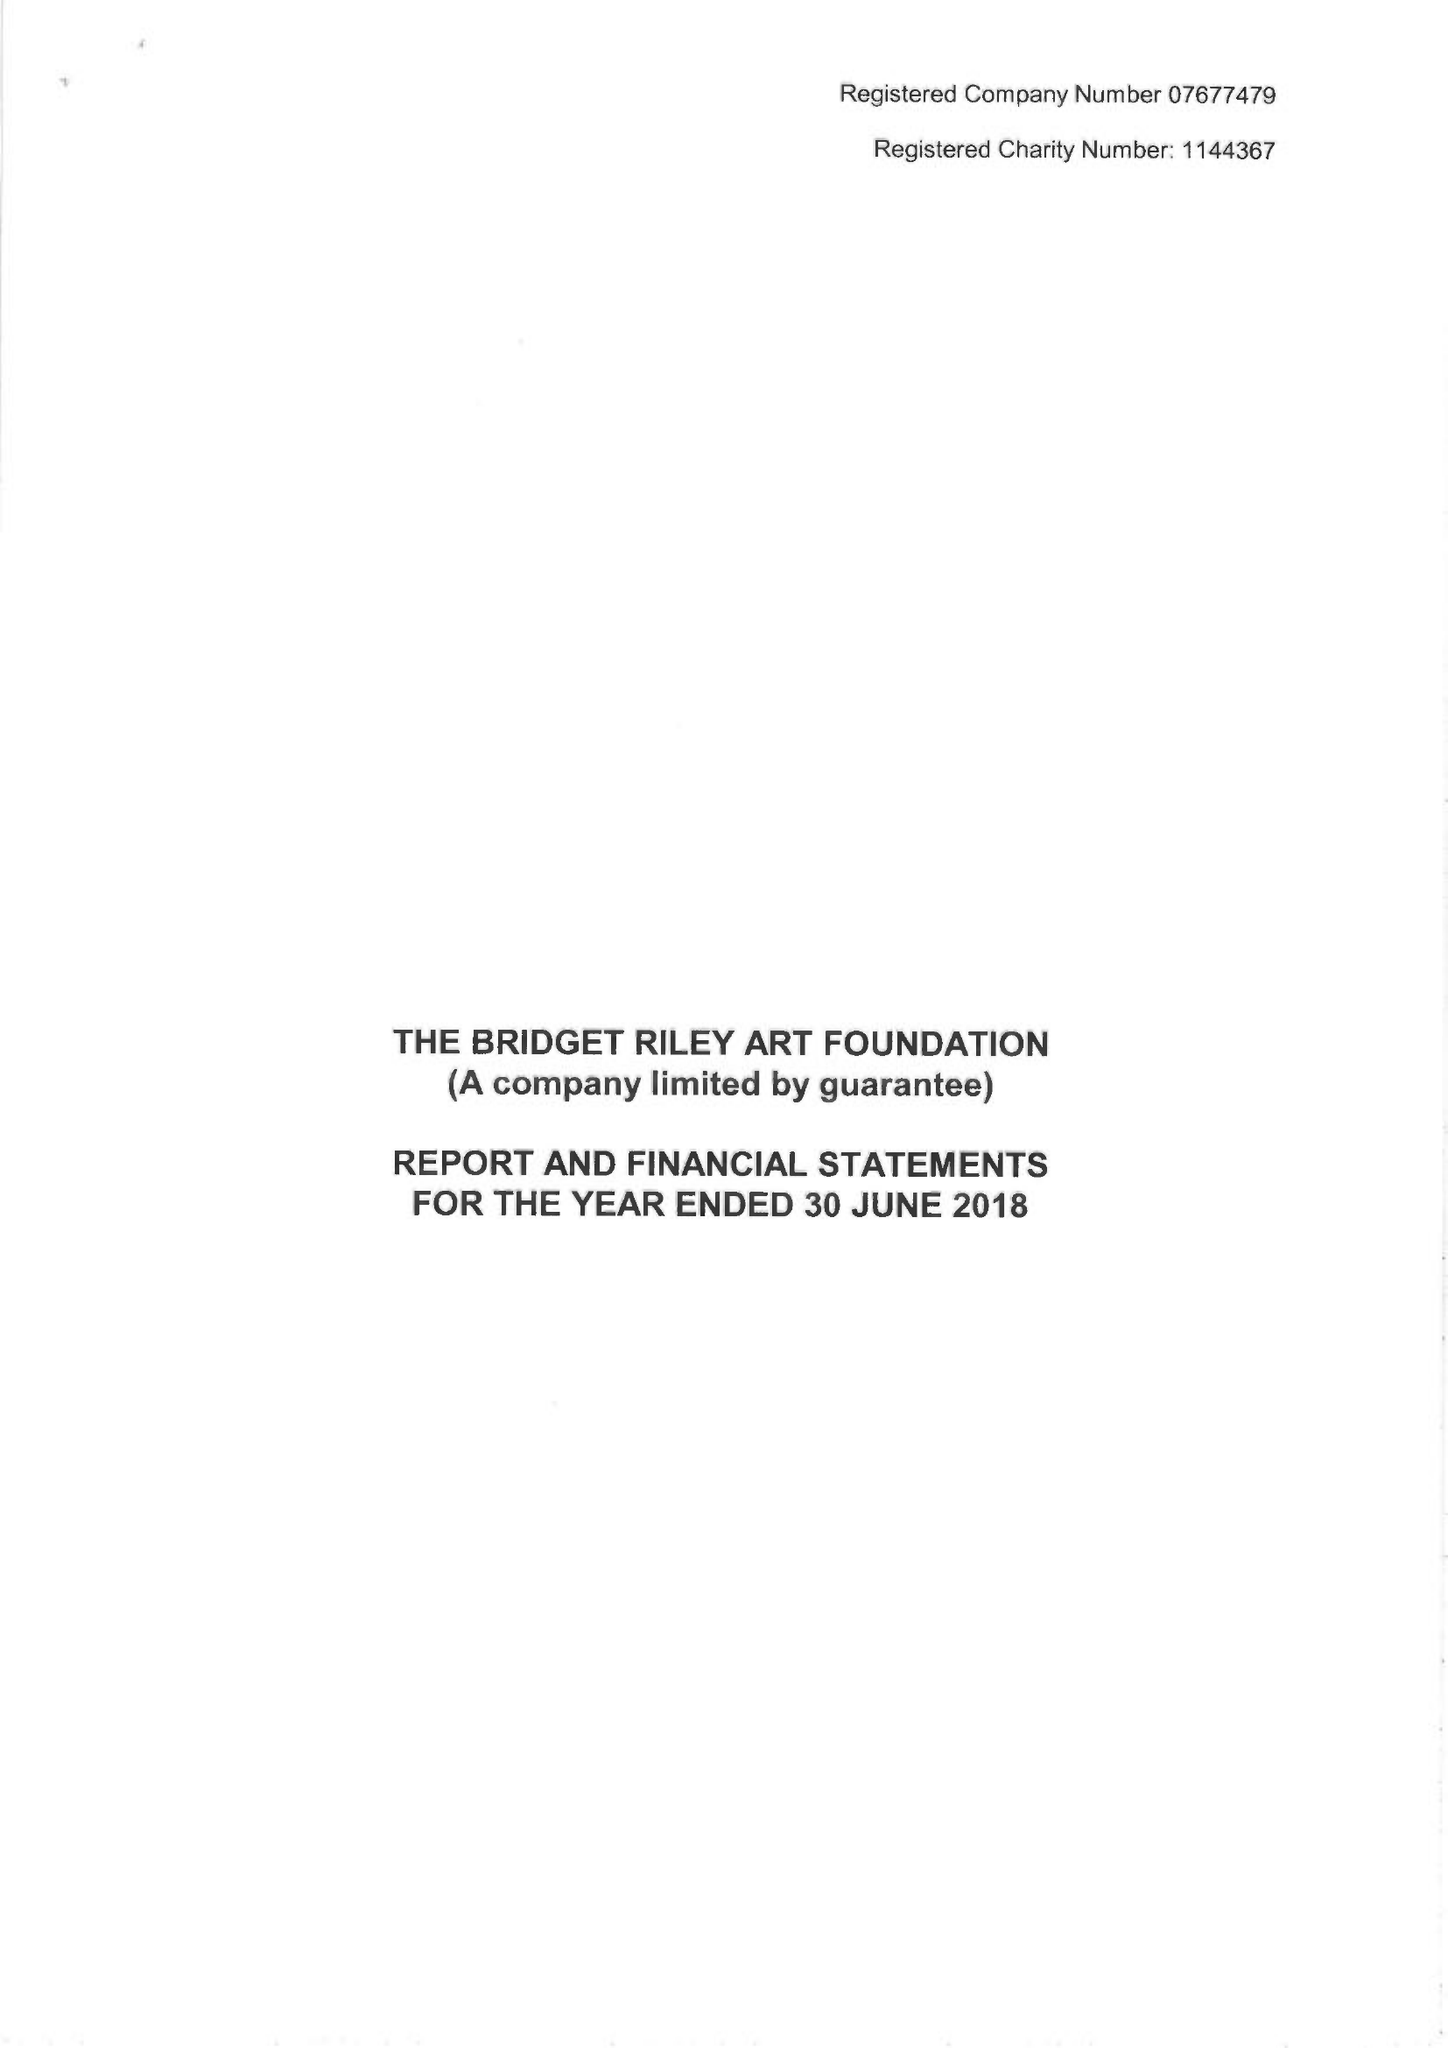What is the value for the report_date?
Answer the question using a single word or phrase. 2018-06-30 